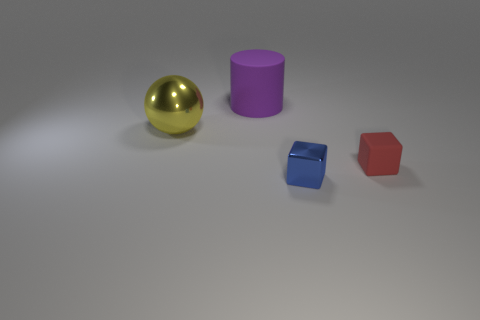Subtract all spheres. How many objects are left? 3 Add 4 gray rubber cylinders. How many objects exist? 8 Subtract 1 cylinders. How many cylinders are left? 0 Subtract all small yellow rubber balls. Subtract all cubes. How many objects are left? 2 Add 3 blue metal cubes. How many blue metal cubes are left? 4 Add 2 red matte cubes. How many red matte cubes exist? 3 Subtract all blue cubes. How many cubes are left? 1 Subtract 1 yellow balls. How many objects are left? 3 Subtract all purple cubes. Subtract all yellow balls. How many cubes are left? 2 